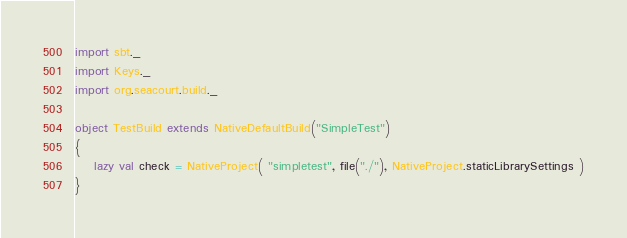Convert code to text. <code><loc_0><loc_0><loc_500><loc_500><_Scala_>import sbt._
import Keys._
import org.seacourt.build._

object TestBuild extends NativeDefaultBuild("SimpleTest")
{
    lazy val check = NativeProject( "simpletest", file("./"), NativeProject.staticLibrarySettings )
}

</code> 